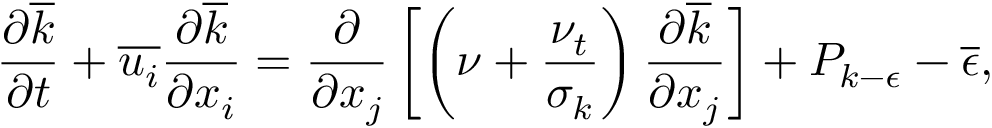<formula> <loc_0><loc_0><loc_500><loc_500>\frac { \partial \overline { k } } { \partial t } + \overline { { u _ { i } } } \frac { \partial \overline { k } } { \partial x _ { i } } = \frac { \partial } { \partial x _ { j } } \left [ \left ( \nu + \frac { \nu _ { t } } { \sigma _ { k } } \right ) \frac { \partial \overline { k } } { \partial x _ { j } } \right ] + P _ { k - \epsilon } - \overline { \epsilon } ,</formula> 